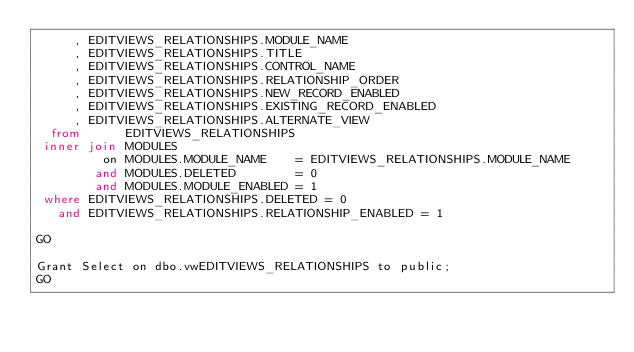Convert code to text. <code><loc_0><loc_0><loc_500><loc_500><_SQL_>     , EDITVIEWS_RELATIONSHIPS.MODULE_NAME
     , EDITVIEWS_RELATIONSHIPS.TITLE
     , EDITVIEWS_RELATIONSHIPS.CONTROL_NAME
     , EDITVIEWS_RELATIONSHIPS.RELATIONSHIP_ORDER
     , EDITVIEWS_RELATIONSHIPS.NEW_RECORD_ENABLED
     , EDITVIEWS_RELATIONSHIPS.EXISTING_RECORD_ENABLED
     , EDITVIEWS_RELATIONSHIPS.ALTERNATE_VIEW
  from      EDITVIEWS_RELATIONSHIPS
 inner join MODULES
         on MODULES.MODULE_NAME    = EDITVIEWS_RELATIONSHIPS.MODULE_NAME
        and MODULES.DELETED        = 0
        and MODULES.MODULE_ENABLED = 1
 where EDITVIEWS_RELATIONSHIPS.DELETED = 0
   and EDITVIEWS_RELATIONSHIPS.RELATIONSHIP_ENABLED = 1

GO

Grant Select on dbo.vwEDITVIEWS_RELATIONSHIPS to public;
GO

</code> 